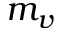<formula> <loc_0><loc_0><loc_500><loc_500>m _ { v }</formula> 